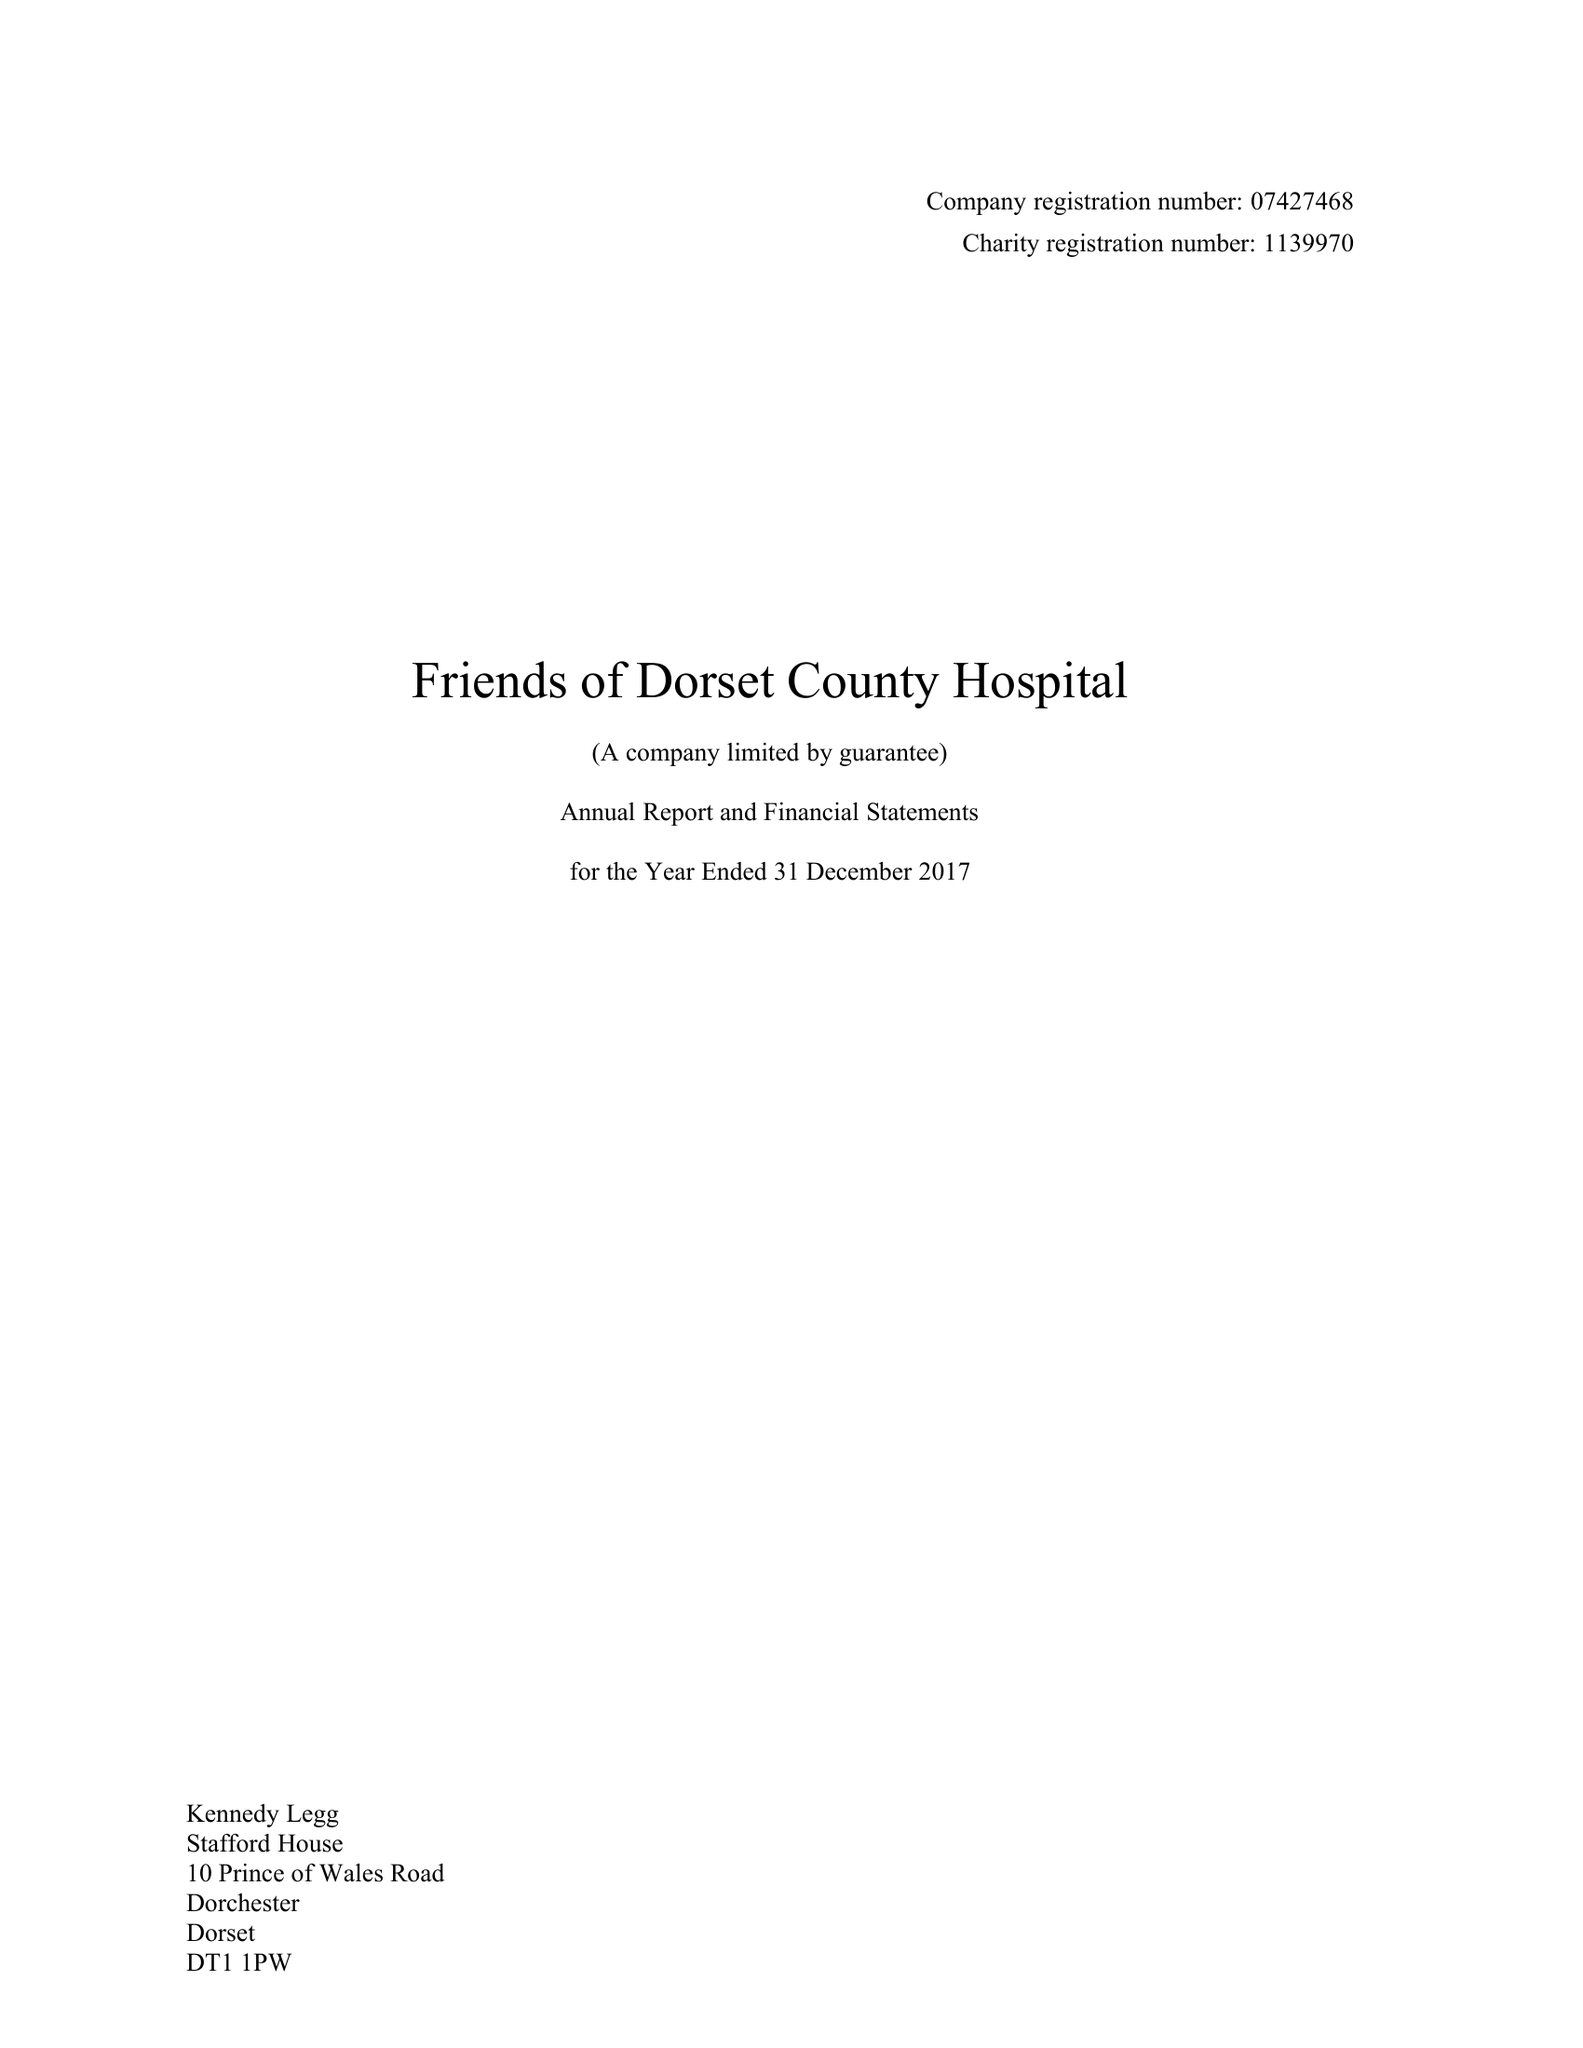What is the value for the address__post_town?
Answer the question using a single word or phrase. DORCHESTER 